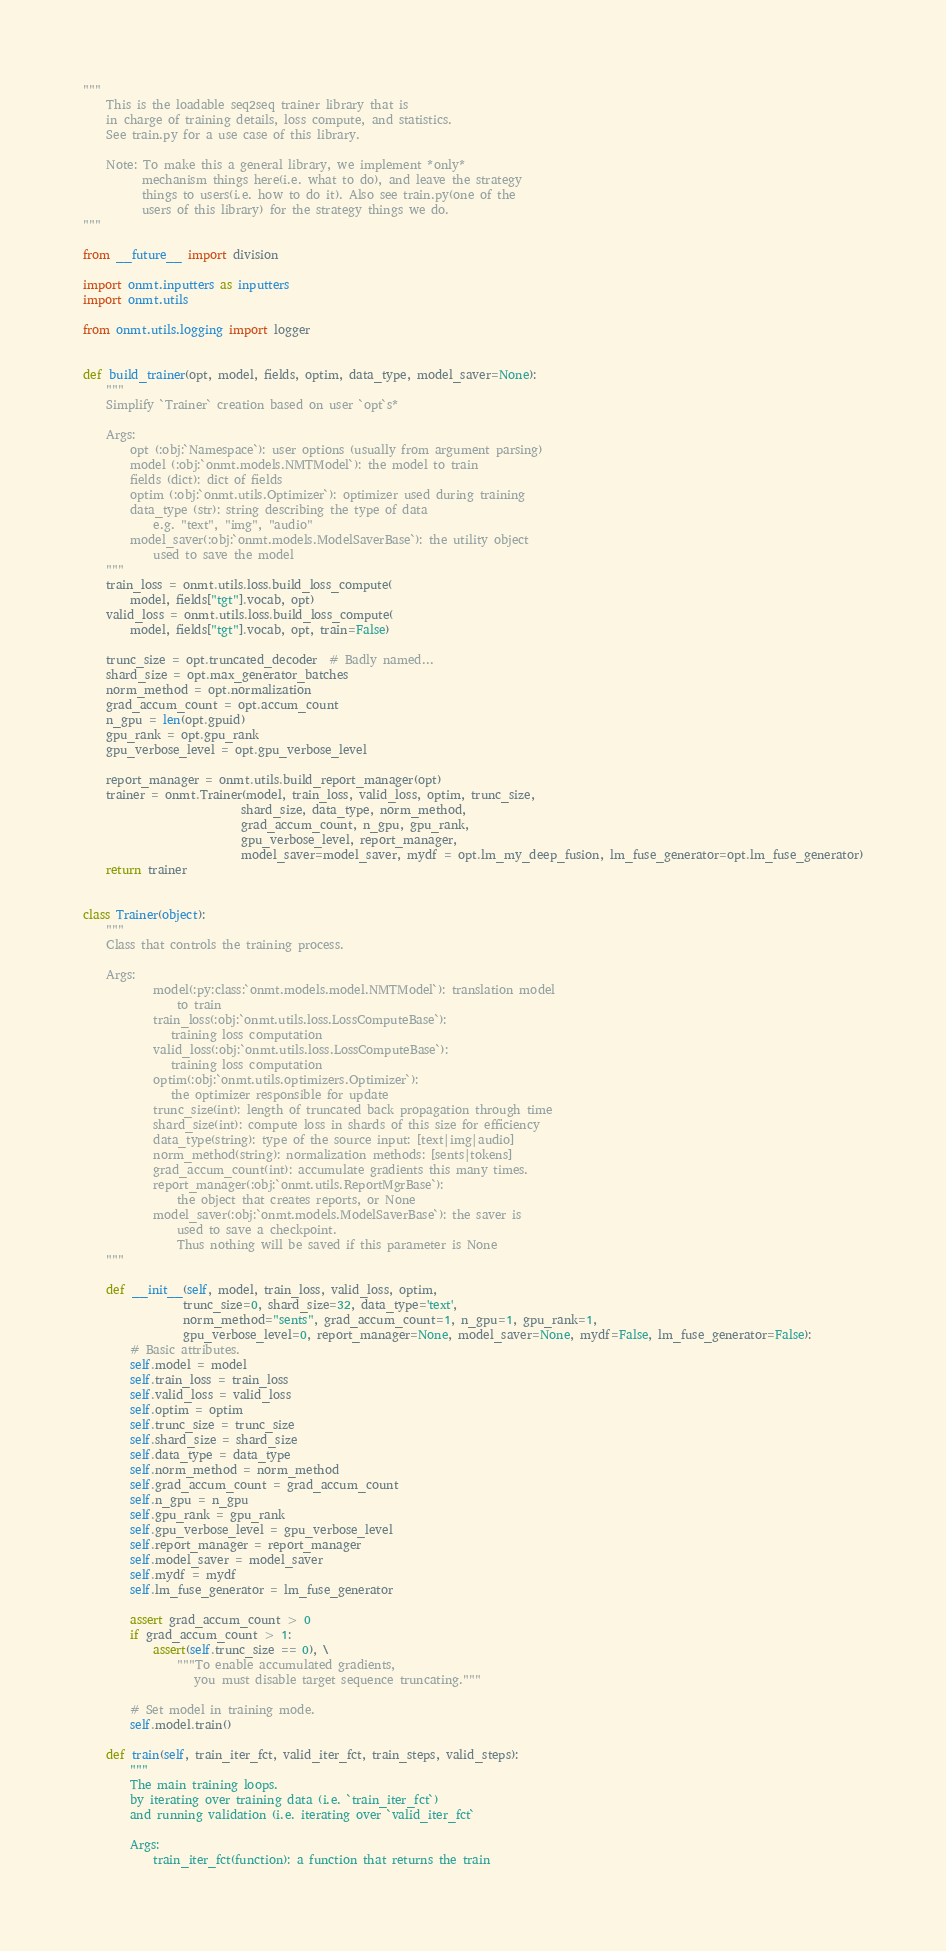<code> <loc_0><loc_0><loc_500><loc_500><_Python_>"""
    This is the loadable seq2seq trainer library that is
    in charge of training details, loss compute, and statistics.
    See train.py for a use case of this library.

    Note: To make this a general library, we implement *only*
          mechanism things here(i.e. what to do), and leave the strategy
          things to users(i.e. how to do it). Also see train.py(one of the
          users of this library) for the strategy things we do.
"""

from __future__ import division

import onmt.inputters as inputters
import onmt.utils

from onmt.utils.logging import logger


def build_trainer(opt, model, fields, optim, data_type, model_saver=None):
    """
    Simplify `Trainer` creation based on user `opt`s*

    Args:
        opt (:obj:`Namespace`): user options (usually from argument parsing)
        model (:obj:`onmt.models.NMTModel`): the model to train
        fields (dict): dict of fields
        optim (:obj:`onmt.utils.Optimizer`): optimizer used during training
        data_type (str): string describing the type of data
            e.g. "text", "img", "audio"
        model_saver(:obj:`onmt.models.ModelSaverBase`): the utility object
            used to save the model
    """
    train_loss = onmt.utils.loss.build_loss_compute(
        model, fields["tgt"].vocab, opt)
    valid_loss = onmt.utils.loss.build_loss_compute(
        model, fields["tgt"].vocab, opt, train=False)

    trunc_size = opt.truncated_decoder  # Badly named...
    shard_size = opt.max_generator_batches
    norm_method = opt.normalization
    grad_accum_count = opt.accum_count
    n_gpu = len(opt.gpuid)
    gpu_rank = opt.gpu_rank
    gpu_verbose_level = opt.gpu_verbose_level

    report_manager = onmt.utils.build_report_manager(opt)
    trainer = onmt.Trainer(model, train_loss, valid_loss, optim, trunc_size,
                           shard_size, data_type, norm_method,
                           grad_accum_count, n_gpu, gpu_rank,
                           gpu_verbose_level, report_manager,
                           model_saver=model_saver, mydf = opt.lm_my_deep_fusion, lm_fuse_generator=opt.lm_fuse_generator)
    return trainer


class Trainer(object):
    """
    Class that controls the training process.

    Args:
            model(:py:class:`onmt.models.model.NMTModel`): translation model
                to train
            train_loss(:obj:`onmt.utils.loss.LossComputeBase`):
               training loss computation
            valid_loss(:obj:`onmt.utils.loss.LossComputeBase`):
               training loss computation
            optim(:obj:`onmt.utils.optimizers.Optimizer`):
               the optimizer responsible for update
            trunc_size(int): length of truncated back propagation through time
            shard_size(int): compute loss in shards of this size for efficiency
            data_type(string): type of the source input: [text|img|audio]
            norm_method(string): normalization methods: [sents|tokens]
            grad_accum_count(int): accumulate gradients this many times.
            report_manager(:obj:`onmt.utils.ReportMgrBase`):
                the object that creates reports, or None
            model_saver(:obj:`onmt.models.ModelSaverBase`): the saver is
                used to save a checkpoint.
                Thus nothing will be saved if this parameter is None
    """

    def __init__(self, model, train_loss, valid_loss, optim,
                 trunc_size=0, shard_size=32, data_type='text',
                 norm_method="sents", grad_accum_count=1, n_gpu=1, gpu_rank=1,
                 gpu_verbose_level=0, report_manager=None, model_saver=None, mydf=False, lm_fuse_generator=False):
        # Basic attributes.
        self.model = model
        self.train_loss = train_loss
        self.valid_loss = valid_loss
        self.optim = optim
        self.trunc_size = trunc_size
        self.shard_size = shard_size
        self.data_type = data_type
        self.norm_method = norm_method
        self.grad_accum_count = grad_accum_count
        self.n_gpu = n_gpu
        self.gpu_rank = gpu_rank
        self.gpu_verbose_level = gpu_verbose_level
        self.report_manager = report_manager
        self.model_saver = model_saver
        self.mydf = mydf
        self.lm_fuse_generator = lm_fuse_generator

        assert grad_accum_count > 0
        if grad_accum_count > 1:
            assert(self.trunc_size == 0), \
                """To enable accumulated gradients,
                   you must disable target sequence truncating."""

        # Set model in training mode.
        self.model.train()

    def train(self, train_iter_fct, valid_iter_fct, train_steps, valid_steps):
        """
        The main training loops.
        by iterating over training data (i.e. `train_iter_fct`)
        and running validation (i.e. iterating over `valid_iter_fct`

        Args:
            train_iter_fct(function): a function that returns the train</code> 